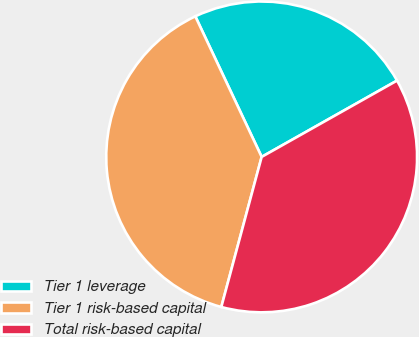<chart> <loc_0><loc_0><loc_500><loc_500><pie_chart><fcel>Tier 1 leverage<fcel>Tier 1 risk-based capital<fcel>Total risk-based capital<nl><fcel>23.85%<fcel>38.8%<fcel>37.35%<nl></chart> 